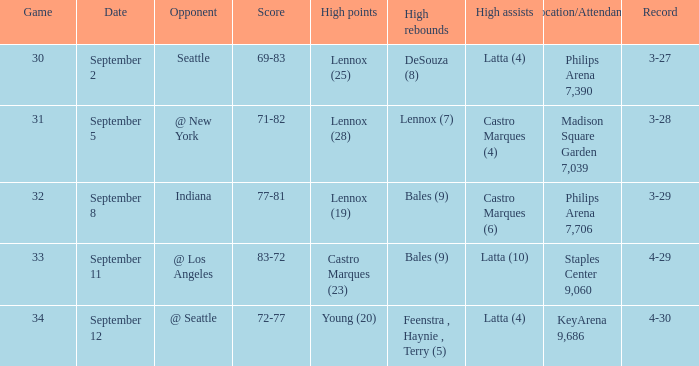Which Location/Attendance has High rebounds of lennox (7)? Madison Square Garden 7,039. 